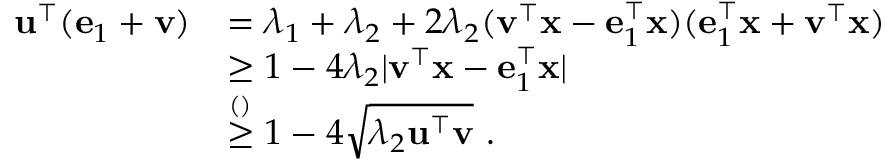<formula> <loc_0><loc_0><loc_500><loc_500>\begin{array} { r l } { \mathbf u ^ { \top } ( \mathbf e _ { 1 } + \mathbf v ) } & { = \lambda _ { 1 } + \lambda _ { 2 } + 2 \lambda _ { 2 } ( \mathbf v ^ { \top } \mathbf x - \mathbf e _ { 1 } ^ { \top } \mathbf x ) ( \mathbf e _ { 1 } ^ { \top } \mathbf x + \mathbf v ^ { \top } \mathbf x ) } \\ & { \geq 1 - 4 \lambda _ { 2 } | \mathbf v ^ { \top } \mathbf x - \mathbf e _ { 1 } ^ { \top } \mathbf x | } \\ & { \overset { ( ) } { \geq } 1 - 4 \sqrt { \lambda _ { 2 } \mathbf u ^ { \top } \mathbf v } . } \end{array}</formula> 